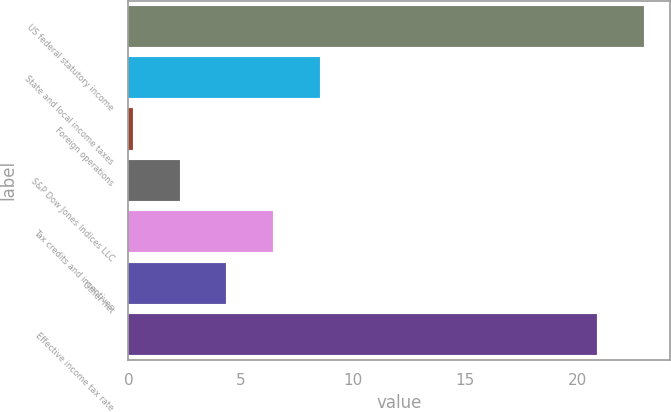<chart> <loc_0><loc_0><loc_500><loc_500><bar_chart><fcel>US federal statutory income<fcel>State and local income taxes<fcel>Foreign operations<fcel>S&P Dow Jones Indices LLC<fcel>Tax credits and incentives<fcel>Other net<fcel>Effective income tax rate<nl><fcel>22.98<fcel>8.52<fcel>0.2<fcel>2.28<fcel>6.44<fcel>4.36<fcel>20.9<nl></chart> 